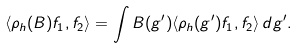Convert formula to latex. <formula><loc_0><loc_0><loc_500><loc_500>\langle \rho _ { h } ( B ) f _ { 1 } , f _ { 2 } \rangle = \int B ( g ^ { \prime } ) \langle \rho _ { h } ( g ^ { \prime } ) f _ { 1 } , f _ { 2 } \rangle \, d g ^ { \prime } .</formula> 